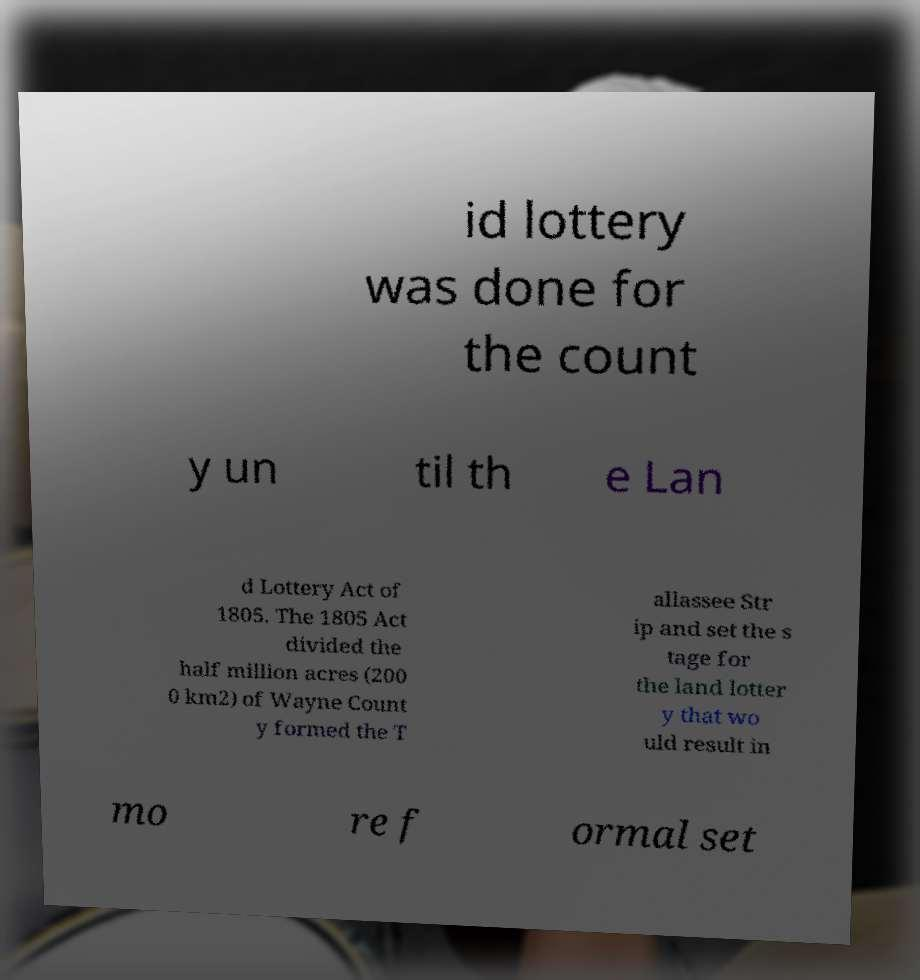I need the written content from this picture converted into text. Can you do that? id lottery was done for the count y un til th e Lan d Lottery Act of 1805. The 1805 Act divided the half million acres (200 0 km2) of Wayne Count y formed the T allassee Str ip and set the s tage for the land lotter y that wo uld result in mo re f ormal set 